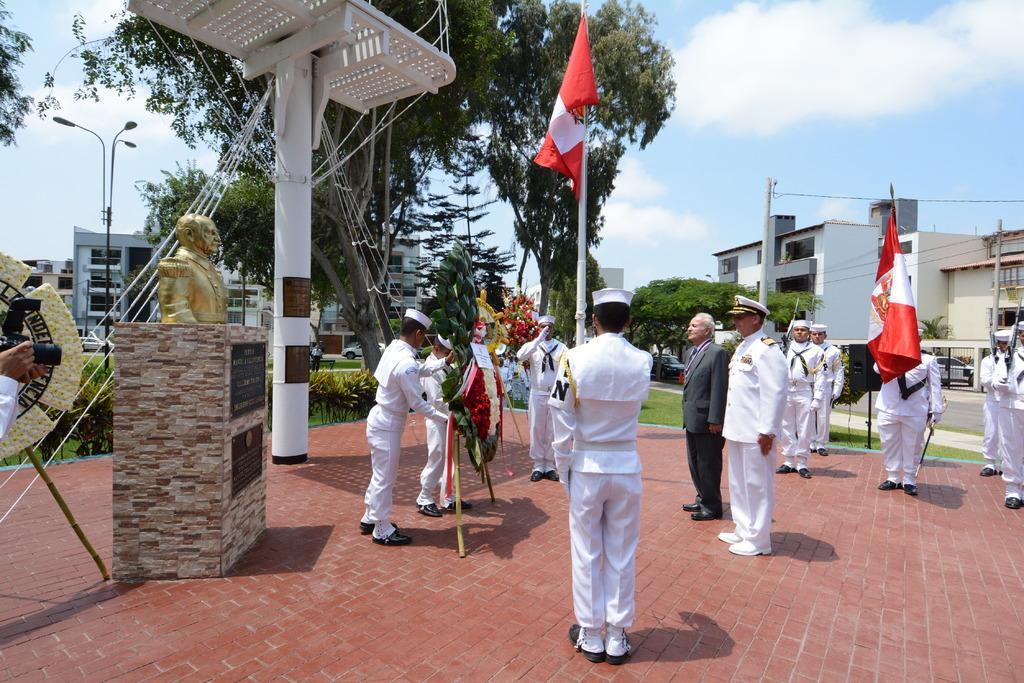Could you give a brief overview of what you see in this image? There are group of people standing. Among them two people are holding a flag in their hands. This is the statue, which is placed on the memorial stone. This is a street light. I think this is a current pole. I can see the buildings and the trees. These are the small bushes. On the left side of the image, I can see a person holding a camera. These are the clouds in the sky. 